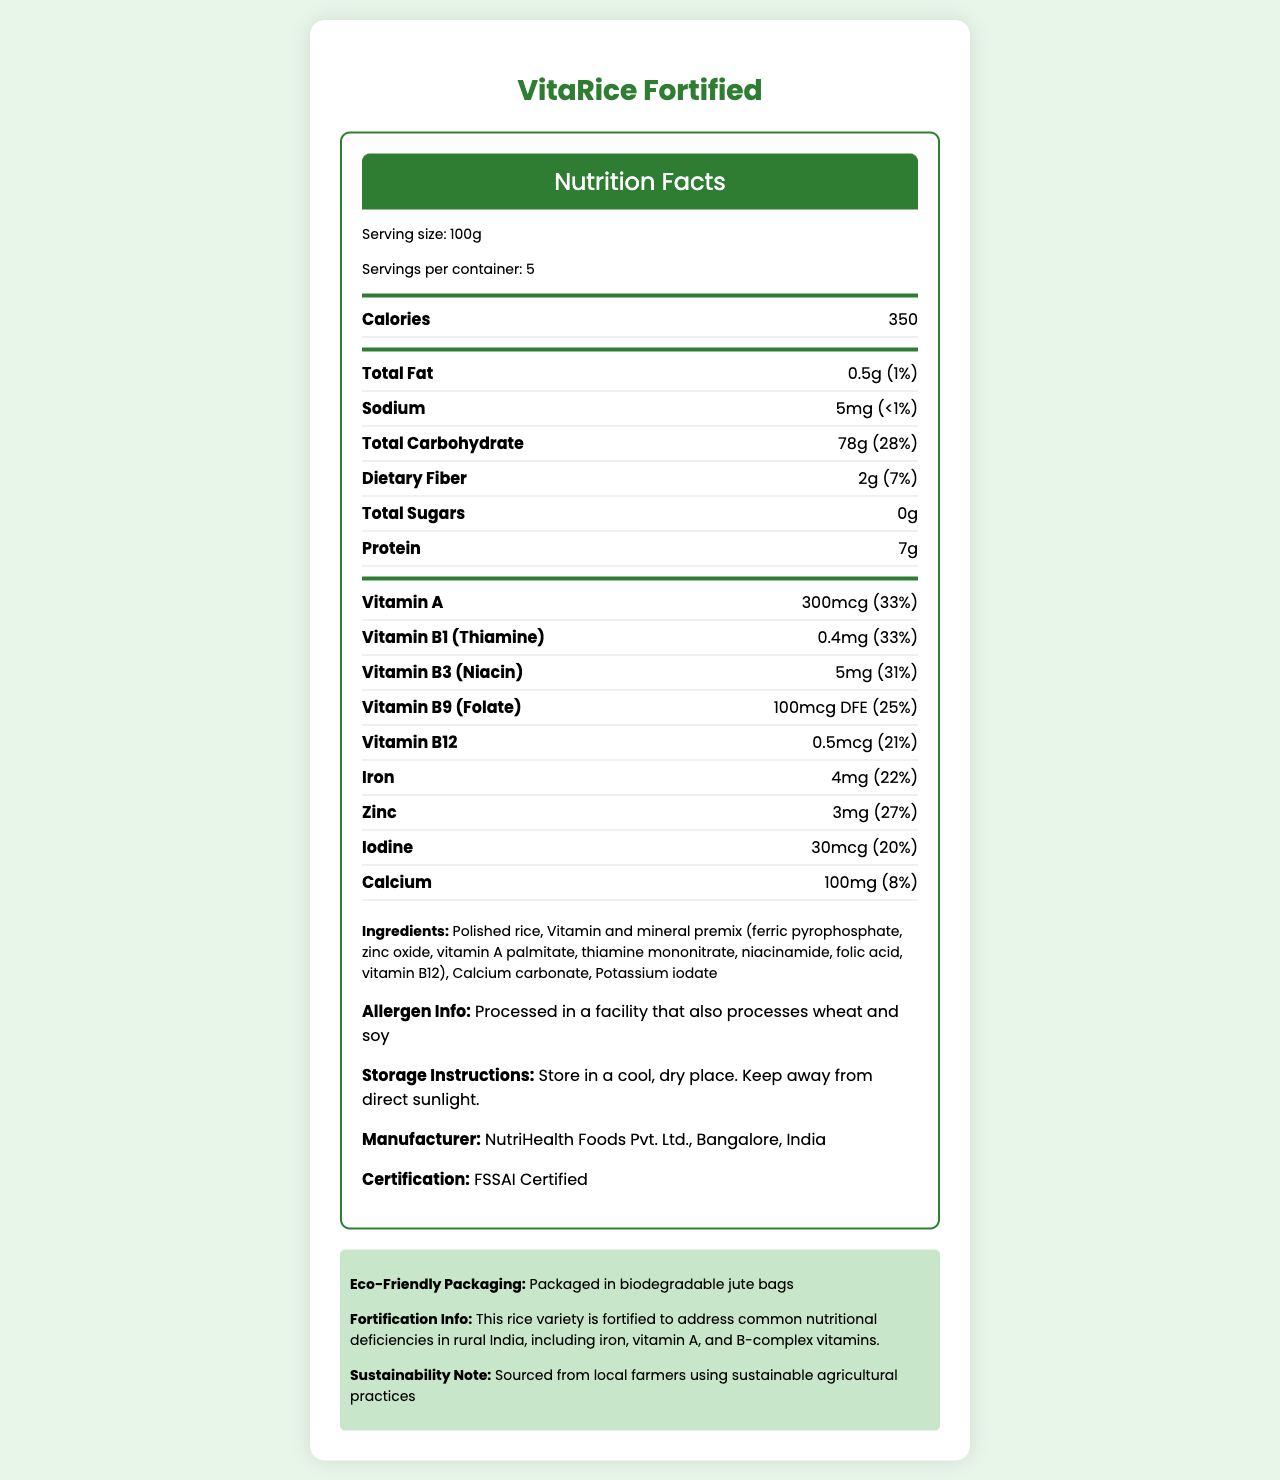what is the serving size for VitaRice Fortified? The serving size is clearly mentioned at the beginning of the nutrition facts label.
Answer: 100g what is the amount of calories per serving? The calories per serving is located in the bold section right after the serving information.
Answer: 350 how much iron does VitaRice Fortified provide per serving? The document lists the iron content in the middle of the nutrient information section.
Answer: 4mg what are the main ingredients of VitaRice Fortified? The main ingredients are listed towards the end of the document.
Answer: Polished rice, Vitamin and mineral premix, Calcium carbonate, Potassium iodate which vitamins are fortified in VitaRice Fortified? The fortified vitamins are specified in the nutritional information section.
Answer: Vitamin A, Vitamin B1 (Thiamine), Vitamin B3 (Niacin), Vitamin B9 (Folate), Vitamin B12 what is the daily value percentage of sodium per serving? A. >1% B. <1% C. 1% D. 2% The daily value percentage of sodium is explicitly mentioned as less than 1%.
Answer: B. <1% what type of packaging is used for VitaRice Fortified? A. Plastic Bags B. Cardboard Boxes C. Biodegradable Jute Bags D. Glass Jars The packaging information is provided in the eco-friendly section at the end.
Answer: C. Biodegradable Jute Bags which organization certified VitaRice Fortified? A. WHO B. UNICEF C. FSSAI D. FDA The certification section shows the product is FSSAI certified.
Answer: C. FSSAI is VitaRice Fortified appropriate for someone with a wheat allergy? The allergen information states that the product is processed in a facility that also processes wheat.
Answer: No could you summarize the main idea of the document? The document provides comprehensive information about the nutritional content, ingredients, health benefits, eco-friendly packaging, and certification of the product.
Answer: VitaRice Fortified is a nutrient-rich rice variety designed to address common nutritional deficiencies in rural India, containing essential vitamins and minerals, and is eco-friendly and FSSAI certified. what is the total cost of a container of VitaRice Fortified? The document does not provide any pricing information.
Answer: Not enough information 